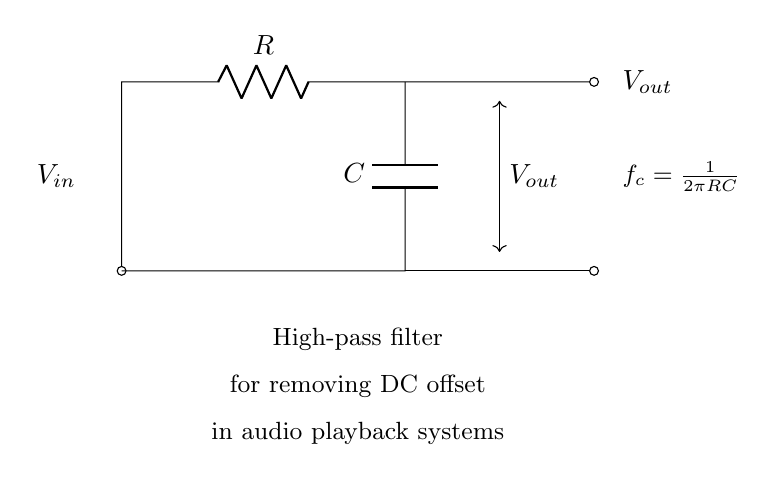What components are in this circuit? The circuit includes a resistor and a capacitor, as indicated by the symbols R and C in the diagram.
Answer: Resistor and Capacitor What does the "high-pass filter" mean in this context? The "high-pass filter" refers to the function of the circuit that allows high frequency signals to pass while blocking low frequency signals, including DC offset.
Answer: High-pass filter What is the output voltage labeled in the circuit? The output voltage is labeled Vout, which is the voltage measured at the output terminals of the filter circuit.
Answer: Vout What is the formula provided for the cutoff frequency? The formula for the cutoff frequency is given as f_c = 1/(2πRC), which describes the frequency at which the circuit begins to attenuate lower frequencies.
Answer: f_c = 1/(2πRC) What is the purpose of removing the DC offset in audio playback systems? Removing the DC offset helps prevent distortion and ensures that the audio signal is centered around zero volts, which is crucial for clear audio reproduction.
Answer: Clear audio reproduction At what connection point does the input voltage enter the circuit? The input voltage enters the circuit at the point labeled Vin, which is connected to the circuit's initial entry point.
Answer: Vin What happens to low-frequency signals in this circuit? Low-frequency signals are attenuated or blocked, which means they cannot pass through and are effectively removed from the output signal.
Answer: Removed 